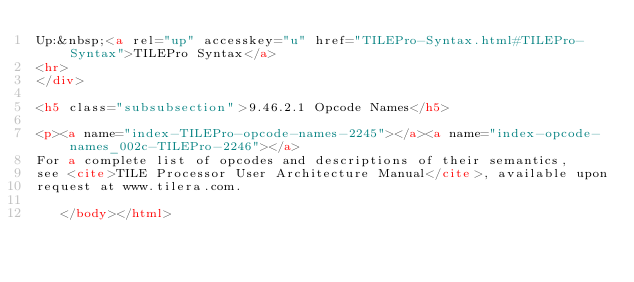Convert code to text. <code><loc_0><loc_0><loc_500><loc_500><_HTML_>Up:&nbsp;<a rel="up" accesskey="u" href="TILEPro-Syntax.html#TILEPro-Syntax">TILEPro Syntax</a>
<hr>
</div>

<h5 class="subsubsection">9.46.2.1 Opcode Names</h5>

<p><a name="index-TILEPro-opcode-names-2245"></a><a name="index-opcode-names_002c-TILEPro-2246"></a>
For a complete list of opcodes and descriptions of their semantics,
see <cite>TILE Processor User Architecture Manual</cite>, available upon
request at www.tilera.com.

   </body></html>

</code> 